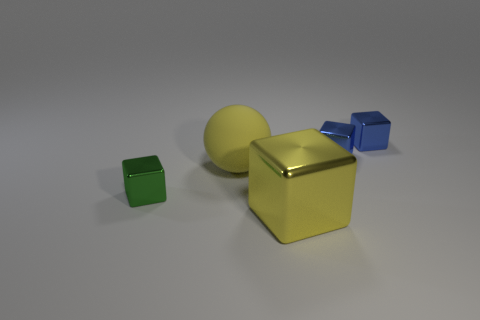Are there the same number of shiny objects that are on the right side of the tiny green block and tiny shiny cubes?
Offer a terse response. Yes. Are there any other things that are the same material as the green object?
Make the answer very short. Yes. There is a big rubber ball; does it have the same color as the big thing in front of the big yellow matte object?
Make the answer very short. Yes. There is a big yellow thing that is on the left side of the yellow object in front of the green cube; are there any tiny green blocks right of it?
Your response must be concise. No. Is the number of tiny green cubes behind the yellow block less than the number of blocks?
Give a very brief answer. Yes. How many other things are there of the same shape as the big metallic object?
Your answer should be compact. 3. How many things are tiny metallic things to the right of the green metallic block or large things that are behind the big yellow metallic object?
Provide a short and direct response. 3. What size is the thing that is both left of the big shiny block and in front of the big yellow rubber thing?
Ensure brevity in your answer.  Small. There is a large object that is in front of the yellow matte thing; is it the same shape as the green thing?
Offer a terse response. Yes. What size is the cube to the left of the big thing that is left of the large yellow object that is right of the sphere?
Keep it short and to the point. Small. 